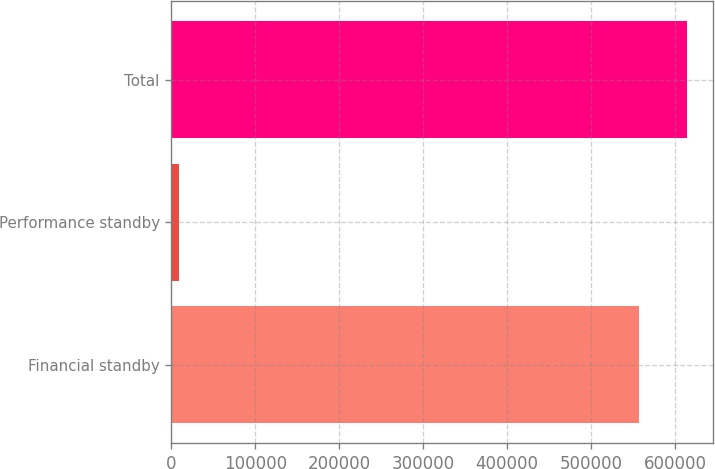<chart> <loc_0><loc_0><loc_500><loc_500><bar_chart><fcel>Financial standby<fcel>Performance standby<fcel>Total<nl><fcel>557304<fcel>8669<fcel>614349<nl></chart> 